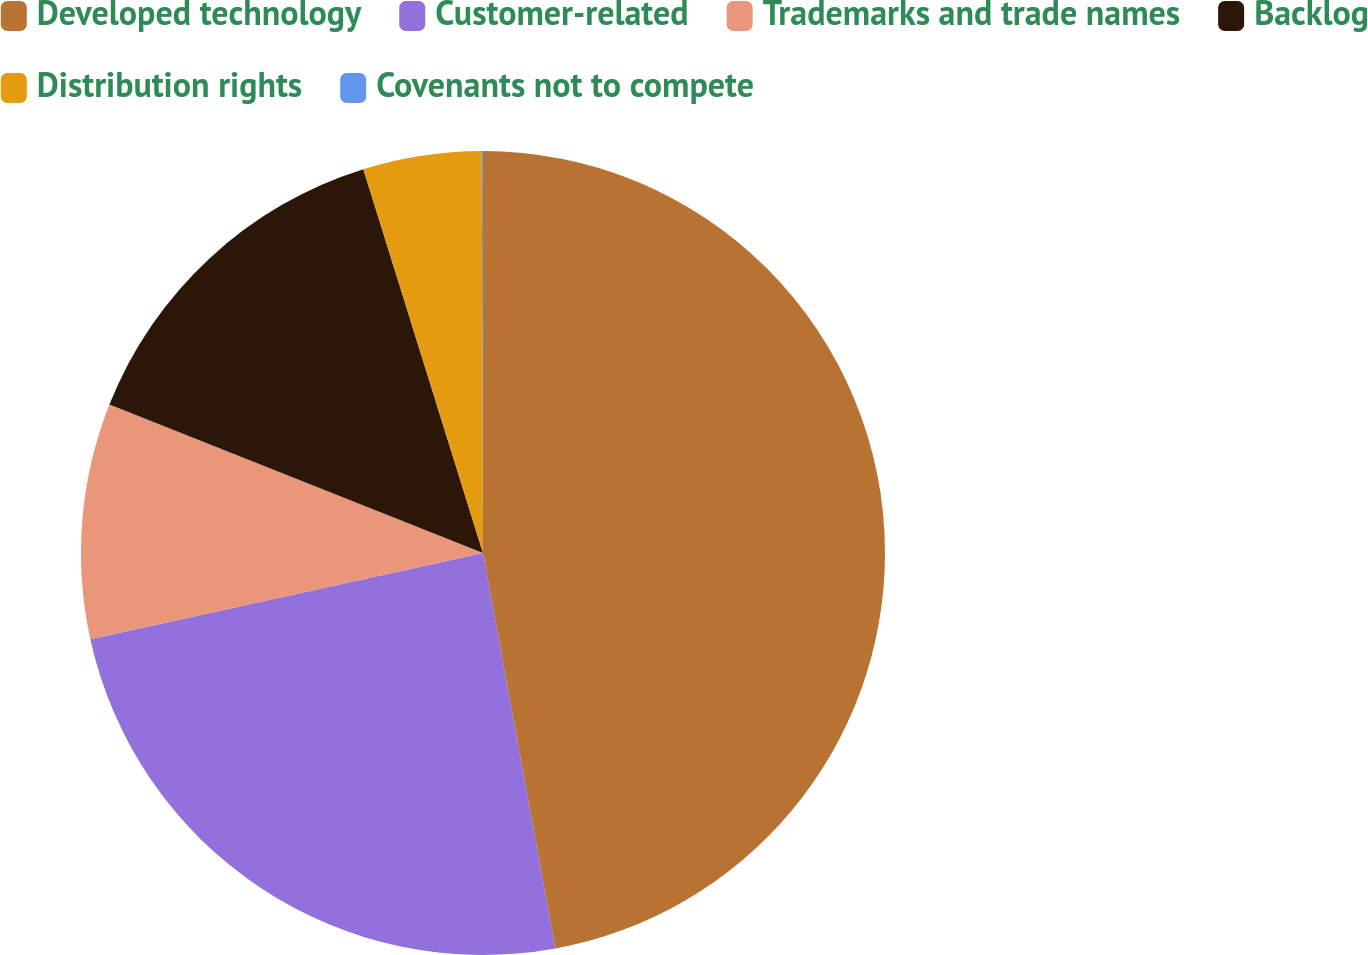Convert chart to OTSL. <chart><loc_0><loc_0><loc_500><loc_500><pie_chart><fcel>Developed technology<fcel>Customer-related<fcel>Trademarks and trade names<fcel>Backlog<fcel>Distribution rights<fcel>Covenants not to compete<nl><fcel>47.12%<fcel>24.44%<fcel>9.46%<fcel>14.17%<fcel>4.76%<fcel>0.05%<nl></chart> 